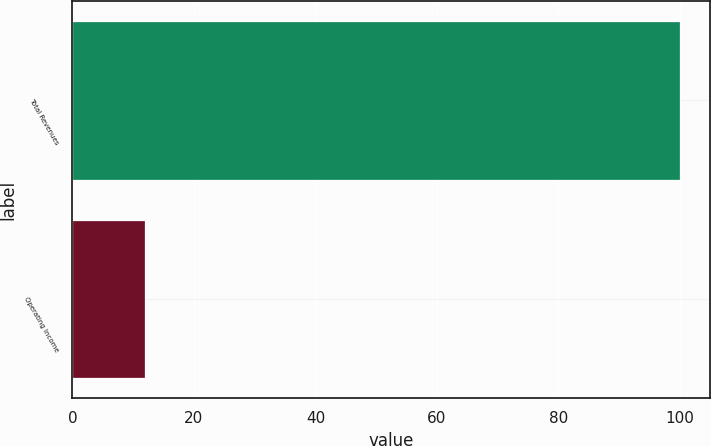Convert chart. <chart><loc_0><loc_0><loc_500><loc_500><bar_chart><fcel>Total Revenues<fcel>Operating Income<nl><fcel>100<fcel>12<nl></chart> 